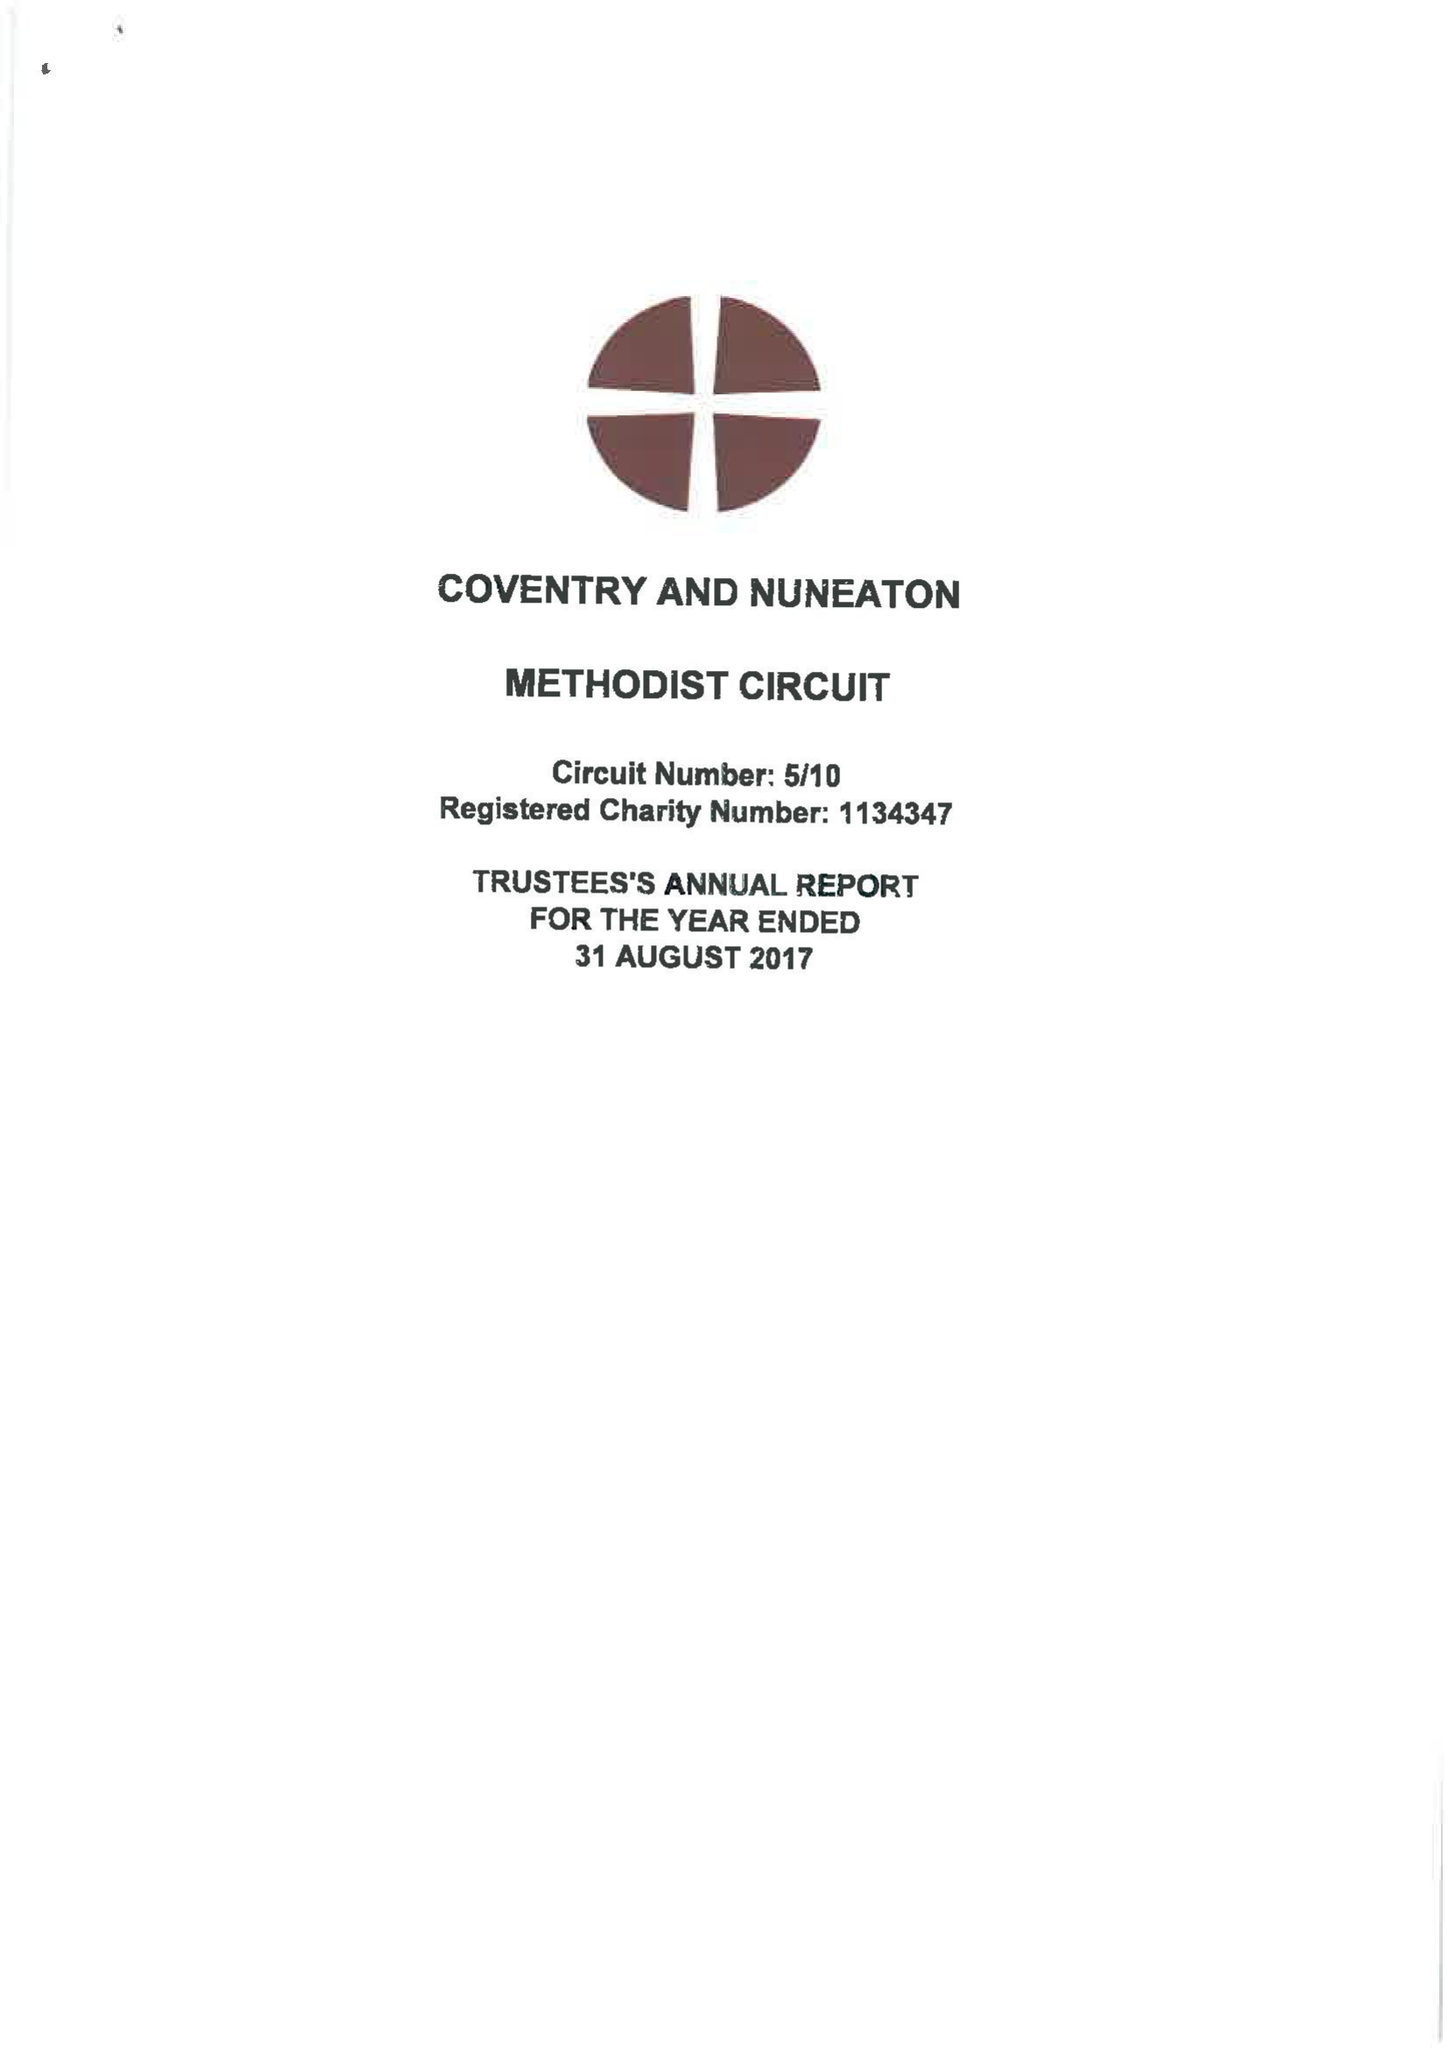What is the value for the spending_annually_in_british_pounds?
Answer the question using a single word or phrase. 463409.00 